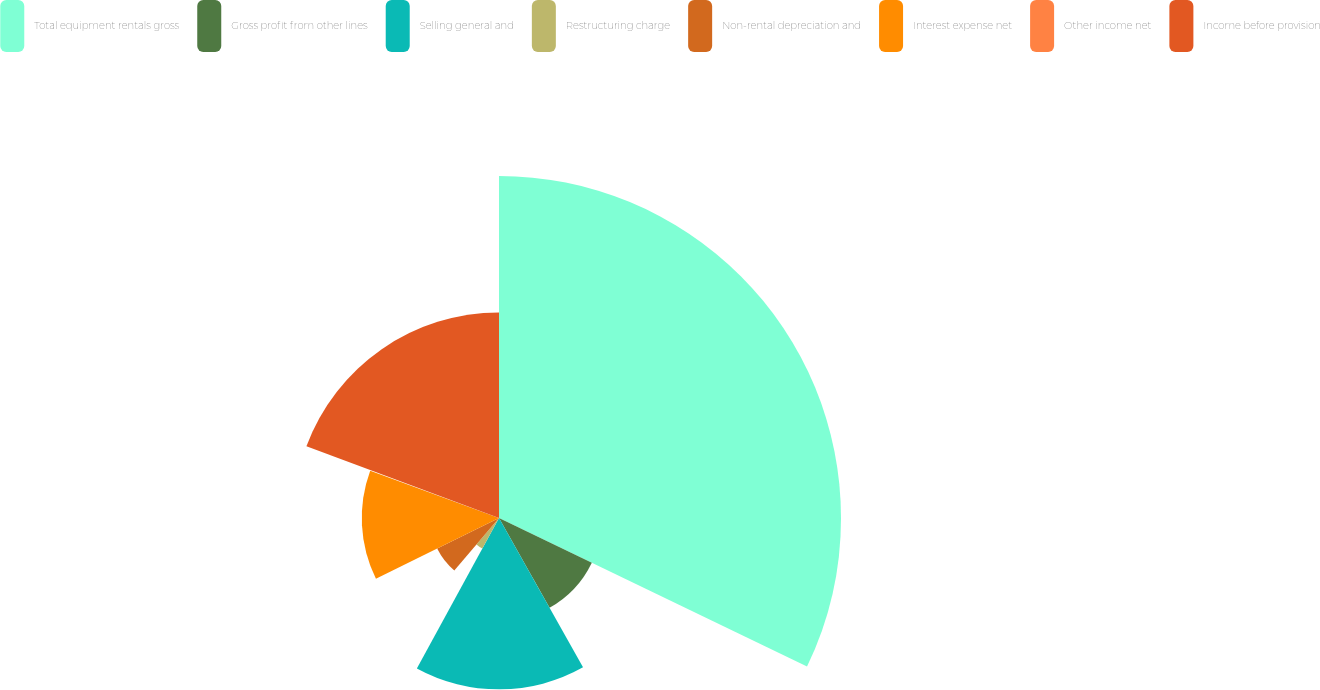Convert chart to OTSL. <chart><loc_0><loc_0><loc_500><loc_500><pie_chart><fcel>Total equipment rentals gross<fcel>Gross profit from other lines<fcel>Selling general and<fcel>Restructuring charge<fcel>Non-rental depreciation and<fcel>Interest expense net<fcel>Other income net<fcel>Income before provision<nl><fcel>32.15%<fcel>9.69%<fcel>16.11%<fcel>3.27%<fcel>6.48%<fcel>12.9%<fcel>0.07%<fcel>19.32%<nl></chart> 